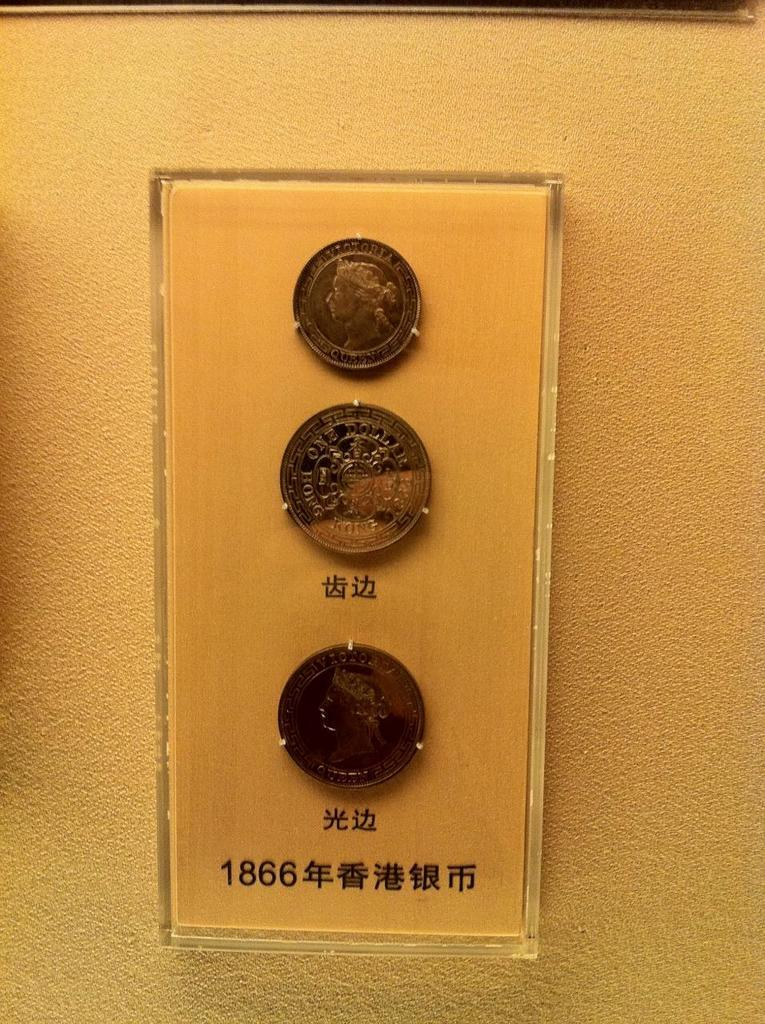<image>
Relay a brief, clear account of the picture shown. three coins hanging on a clear plaque on the wall that says the numbers '1866' 